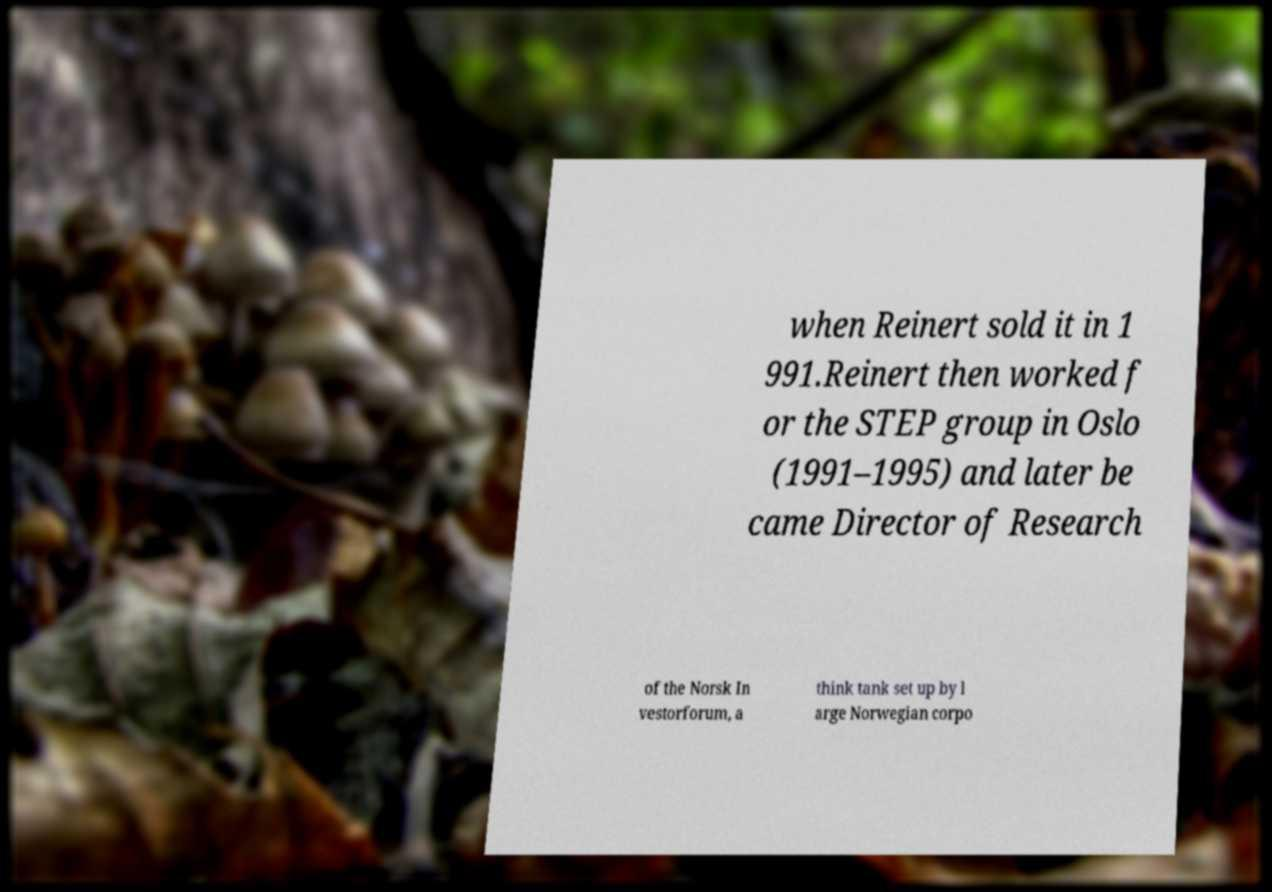For documentation purposes, I need the text within this image transcribed. Could you provide that? when Reinert sold it in 1 991.Reinert then worked f or the STEP group in Oslo (1991–1995) and later be came Director of Research of the Norsk In vestorforum, a think tank set up by l arge Norwegian corpo 